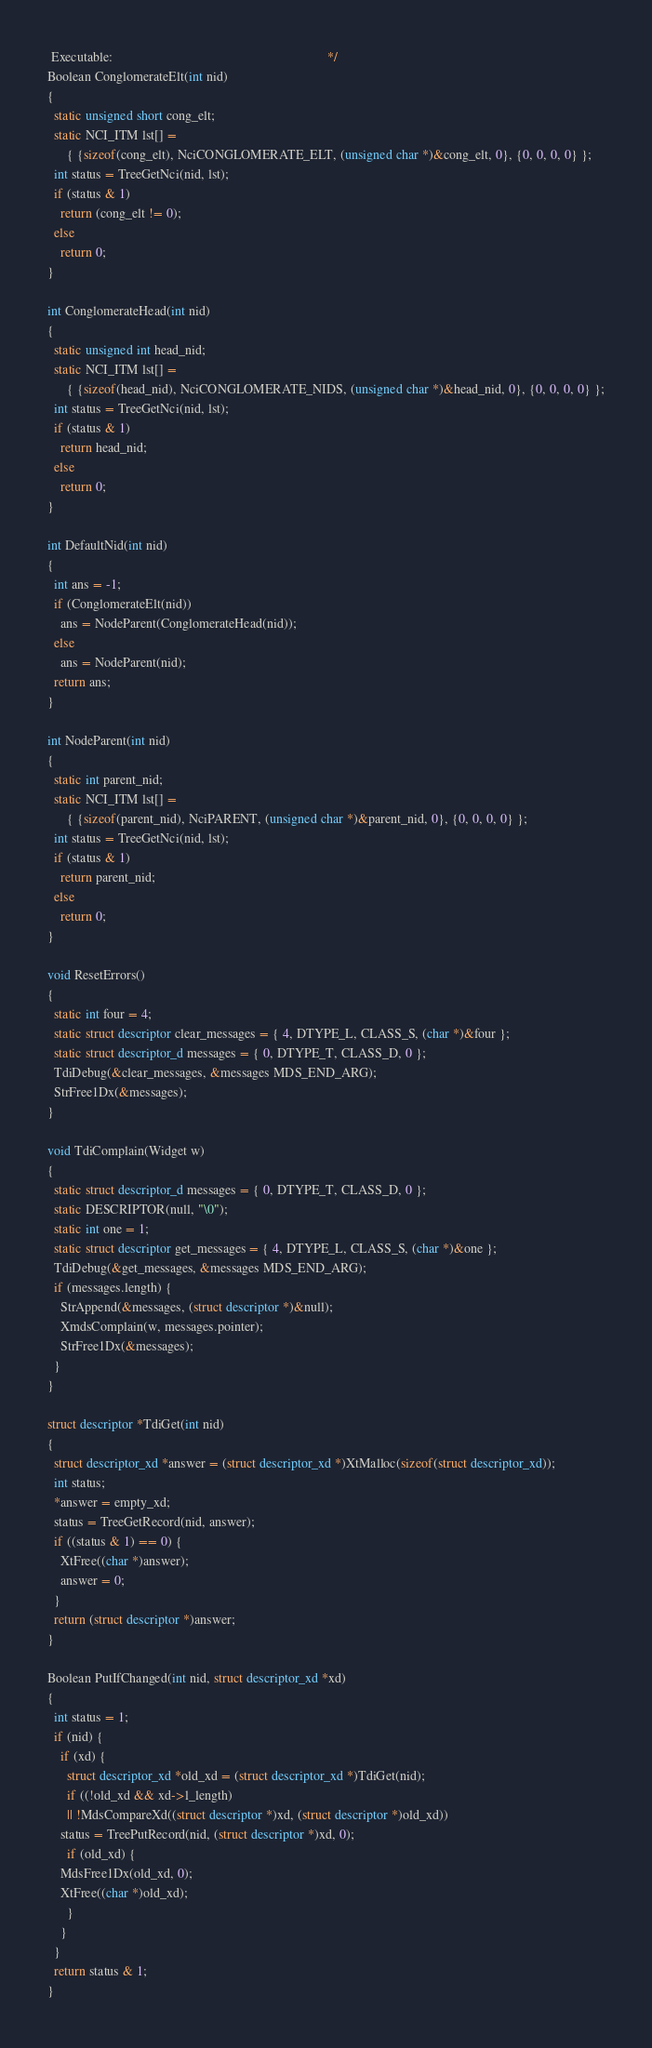Convert code to text. <code><loc_0><loc_0><loc_500><loc_500><_C_> Executable:                                                                  */
Boolean ConglomerateElt(int nid)
{
  static unsigned short cong_elt;
  static NCI_ITM lst[] =
      { {sizeof(cong_elt), NciCONGLOMERATE_ELT, (unsigned char *)&cong_elt, 0}, {0, 0, 0, 0} };
  int status = TreeGetNci(nid, lst);
  if (status & 1)
    return (cong_elt != 0);
  else
    return 0;
}

int ConglomerateHead(int nid)
{
  static unsigned int head_nid;
  static NCI_ITM lst[] =
      { {sizeof(head_nid), NciCONGLOMERATE_NIDS, (unsigned char *)&head_nid, 0}, {0, 0, 0, 0} };
  int status = TreeGetNci(nid, lst);
  if (status & 1)
    return head_nid;
  else
    return 0;
}

int DefaultNid(int nid)
{
  int ans = -1;
  if (ConglomerateElt(nid))
    ans = NodeParent(ConglomerateHead(nid));
  else
    ans = NodeParent(nid);
  return ans;
}

int NodeParent(int nid)
{
  static int parent_nid;
  static NCI_ITM lst[] =
      { {sizeof(parent_nid), NciPARENT, (unsigned char *)&parent_nid, 0}, {0, 0, 0, 0} };
  int status = TreeGetNci(nid, lst);
  if (status & 1)
    return parent_nid;
  else
    return 0;
}

void ResetErrors()
{
  static int four = 4;
  static struct descriptor clear_messages = { 4, DTYPE_L, CLASS_S, (char *)&four };
  static struct descriptor_d messages = { 0, DTYPE_T, CLASS_D, 0 };
  TdiDebug(&clear_messages, &messages MDS_END_ARG);
  StrFree1Dx(&messages);
}

void TdiComplain(Widget w)
{
  static struct descriptor_d messages = { 0, DTYPE_T, CLASS_D, 0 };
  static DESCRIPTOR(null, "\0");
  static int one = 1;
  static struct descriptor get_messages = { 4, DTYPE_L, CLASS_S, (char *)&one };
  TdiDebug(&get_messages, &messages MDS_END_ARG);
  if (messages.length) {
    StrAppend(&messages, (struct descriptor *)&null);
    XmdsComplain(w, messages.pointer);
    StrFree1Dx(&messages);
  }
}

struct descriptor *TdiGet(int nid)
{
  struct descriptor_xd *answer = (struct descriptor_xd *)XtMalloc(sizeof(struct descriptor_xd));
  int status;
  *answer = empty_xd;
  status = TreeGetRecord(nid, answer);
  if ((status & 1) == 0) {
    XtFree((char *)answer);
    answer = 0;
  }
  return (struct descriptor *)answer;
}

Boolean PutIfChanged(int nid, struct descriptor_xd *xd)
{
  int status = 1;
  if (nid) {
    if (xd) {
      struct descriptor_xd *old_xd = (struct descriptor_xd *)TdiGet(nid);
      if ((!old_xd && xd->l_length)
	  || !MdsCompareXd((struct descriptor *)xd, (struct descriptor *)old_xd))
	status = TreePutRecord(nid, (struct descriptor *)xd, 0);
      if (old_xd) {
	MdsFree1Dx(old_xd, 0);
	XtFree((char *)old_xd);
      }
    }
  }
  return status & 1;
}
</code> 